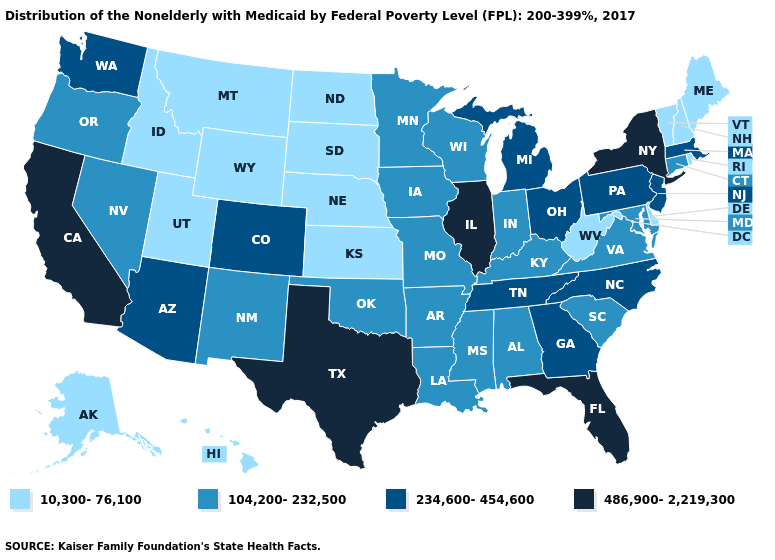Does Vermont have the same value as Ohio?
Answer briefly. No. Among the states that border Ohio , which have the highest value?
Concise answer only. Michigan, Pennsylvania. Does Arizona have the same value as Pennsylvania?
Keep it brief. Yes. Which states have the lowest value in the USA?
Answer briefly. Alaska, Delaware, Hawaii, Idaho, Kansas, Maine, Montana, Nebraska, New Hampshire, North Dakota, Rhode Island, South Dakota, Utah, Vermont, West Virginia, Wyoming. What is the value of Alabama?
Concise answer only. 104,200-232,500. Name the states that have a value in the range 104,200-232,500?
Be succinct. Alabama, Arkansas, Connecticut, Indiana, Iowa, Kentucky, Louisiana, Maryland, Minnesota, Mississippi, Missouri, Nevada, New Mexico, Oklahoma, Oregon, South Carolina, Virginia, Wisconsin. Name the states that have a value in the range 104,200-232,500?
Be succinct. Alabama, Arkansas, Connecticut, Indiana, Iowa, Kentucky, Louisiana, Maryland, Minnesota, Mississippi, Missouri, Nevada, New Mexico, Oklahoma, Oregon, South Carolina, Virginia, Wisconsin. Name the states that have a value in the range 10,300-76,100?
Quick response, please. Alaska, Delaware, Hawaii, Idaho, Kansas, Maine, Montana, Nebraska, New Hampshire, North Dakota, Rhode Island, South Dakota, Utah, Vermont, West Virginia, Wyoming. What is the lowest value in states that border Idaho?
Short answer required. 10,300-76,100. Name the states that have a value in the range 10,300-76,100?
Give a very brief answer. Alaska, Delaware, Hawaii, Idaho, Kansas, Maine, Montana, Nebraska, New Hampshire, North Dakota, Rhode Island, South Dakota, Utah, Vermont, West Virginia, Wyoming. Name the states that have a value in the range 10,300-76,100?
Be succinct. Alaska, Delaware, Hawaii, Idaho, Kansas, Maine, Montana, Nebraska, New Hampshire, North Dakota, Rhode Island, South Dakota, Utah, Vermont, West Virginia, Wyoming. What is the highest value in the Northeast ?
Answer briefly. 486,900-2,219,300. Name the states that have a value in the range 234,600-454,600?
Short answer required. Arizona, Colorado, Georgia, Massachusetts, Michigan, New Jersey, North Carolina, Ohio, Pennsylvania, Tennessee, Washington. Does New Hampshire have the highest value in the USA?
Short answer required. No. Is the legend a continuous bar?
Be succinct. No. 